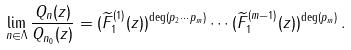Convert formula to latex. <formula><loc_0><loc_0><loc_500><loc_500>\lim _ { n \in \Lambda } \frac { Q _ { n } ( z ) } { Q _ { n _ { 0 } } ( z ) } = ( \widetilde { F } _ { 1 } ^ { ( 1 ) } ( z ) ) ^ { \deg ( p _ { 2 } \cdots p _ { m } ) } \cdots ( \widetilde { F } _ { 1 } ^ { ( m - 1 ) } ( z ) ) ^ { \deg ( p _ { m } ) } \, .</formula> 